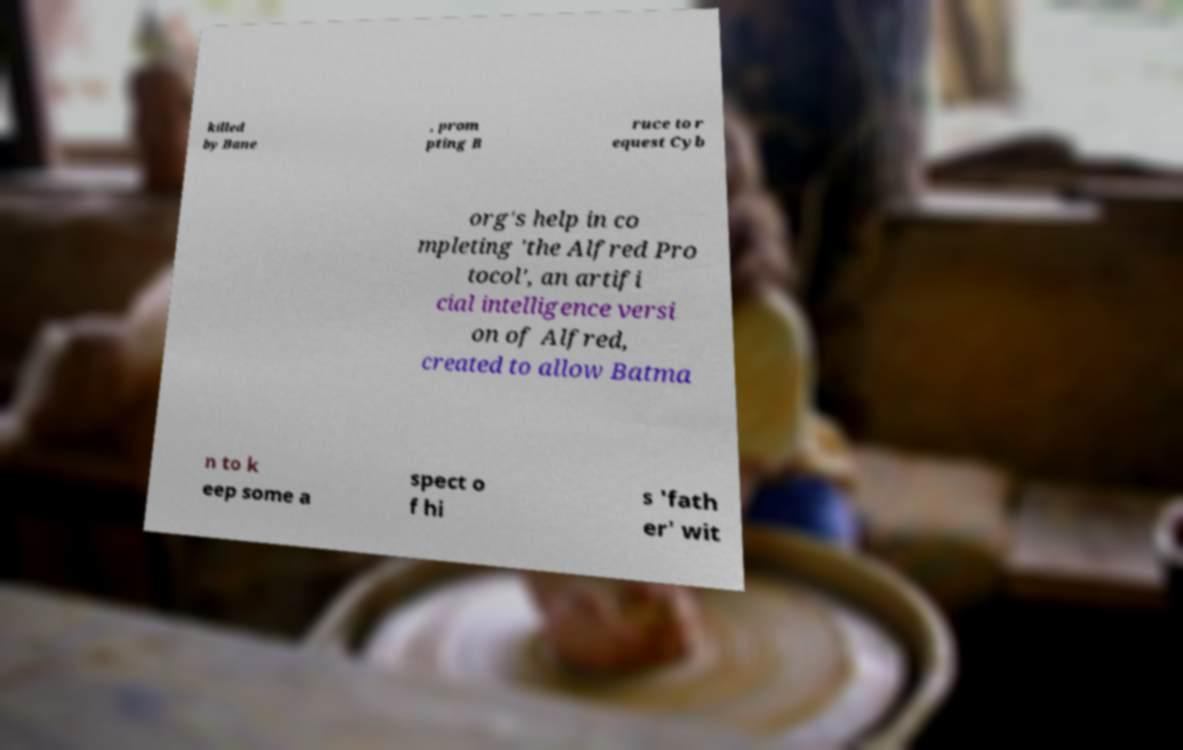Please identify and transcribe the text found in this image. killed by Bane , prom pting B ruce to r equest Cyb org's help in co mpleting 'the Alfred Pro tocol', an artifi cial intelligence versi on of Alfred, created to allow Batma n to k eep some a spect o f hi s 'fath er' wit 